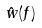Convert formula to latex. <formula><loc_0><loc_0><loc_500><loc_500>\hat { w } ( f )</formula> 